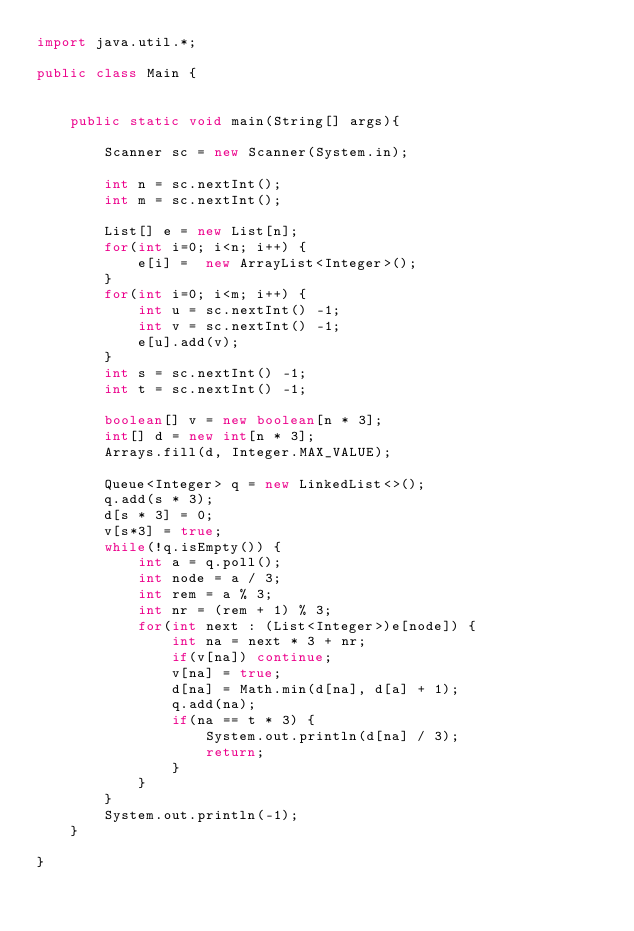Convert code to text. <code><loc_0><loc_0><loc_500><loc_500><_Java_>import java.util.*;

public class Main {


    public static void main(String[] args){

        Scanner sc = new Scanner(System.in);

        int n = sc.nextInt();
        int m = sc.nextInt();

        List[] e = new List[n];
        for(int i=0; i<n; i++) {
            e[i] =  new ArrayList<Integer>();
        }
        for(int i=0; i<m; i++) {
            int u = sc.nextInt() -1;
            int v = sc.nextInt() -1;
            e[u].add(v);
        }
        int s = sc.nextInt() -1;
        int t = sc.nextInt() -1;

        boolean[] v = new boolean[n * 3];
        int[] d = new int[n * 3];
        Arrays.fill(d, Integer.MAX_VALUE);

        Queue<Integer> q = new LinkedList<>();
        q.add(s * 3);
        d[s * 3] = 0;
        v[s*3] = true;
        while(!q.isEmpty()) {
            int a = q.poll();
            int node = a / 3;
            int rem = a % 3;
            int nr = (rem + 1) % 3;
            for(int next : (List<Integer>)e[node]) {
                int na = next * 3 + nr;
                if(v[na]) continue;
                v[na] = true;
                d[na] = Math.min(d[na], d[a] + 1);
                q.add(na);
                if(na == t * 3) {
                    System.out.println(d[na] / 3);
                    return;
                }
            }
        }
        System.out.println(-1);
    }

}
</code> 